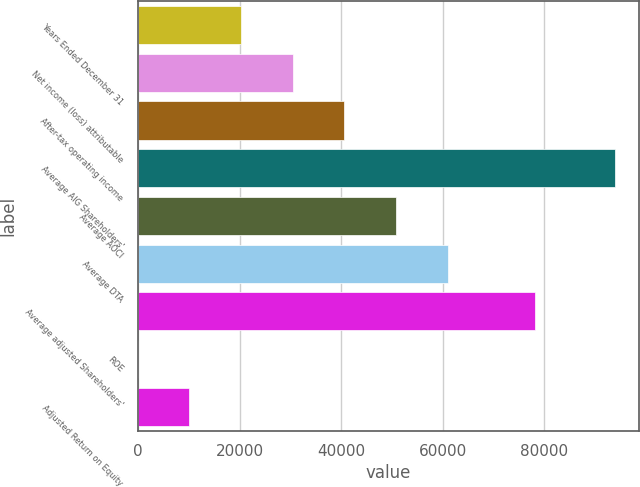Convert chart. <chart><loc_0><loc_0><loc_500><loc_500><bar_chart><fcel>Years Ended December 31<fcel>Net income (loss) attributable<fcel>After-tax operating income<fcel>Average AIG Shareholders'<fcel>Average AOCI<fcel>Average DTA<fcel>Average adjusted Shareholders'<fcel>ROE<fcel>Adjusted Return on Equity<nl><fcel>20313.4<fcel>30468.9<fcel>40624.5<fcel>93960<fcel>50780.1<fcel>60935.7<fcel>78157<fcel>2.2<fcel>10157.8<nl></chart> 